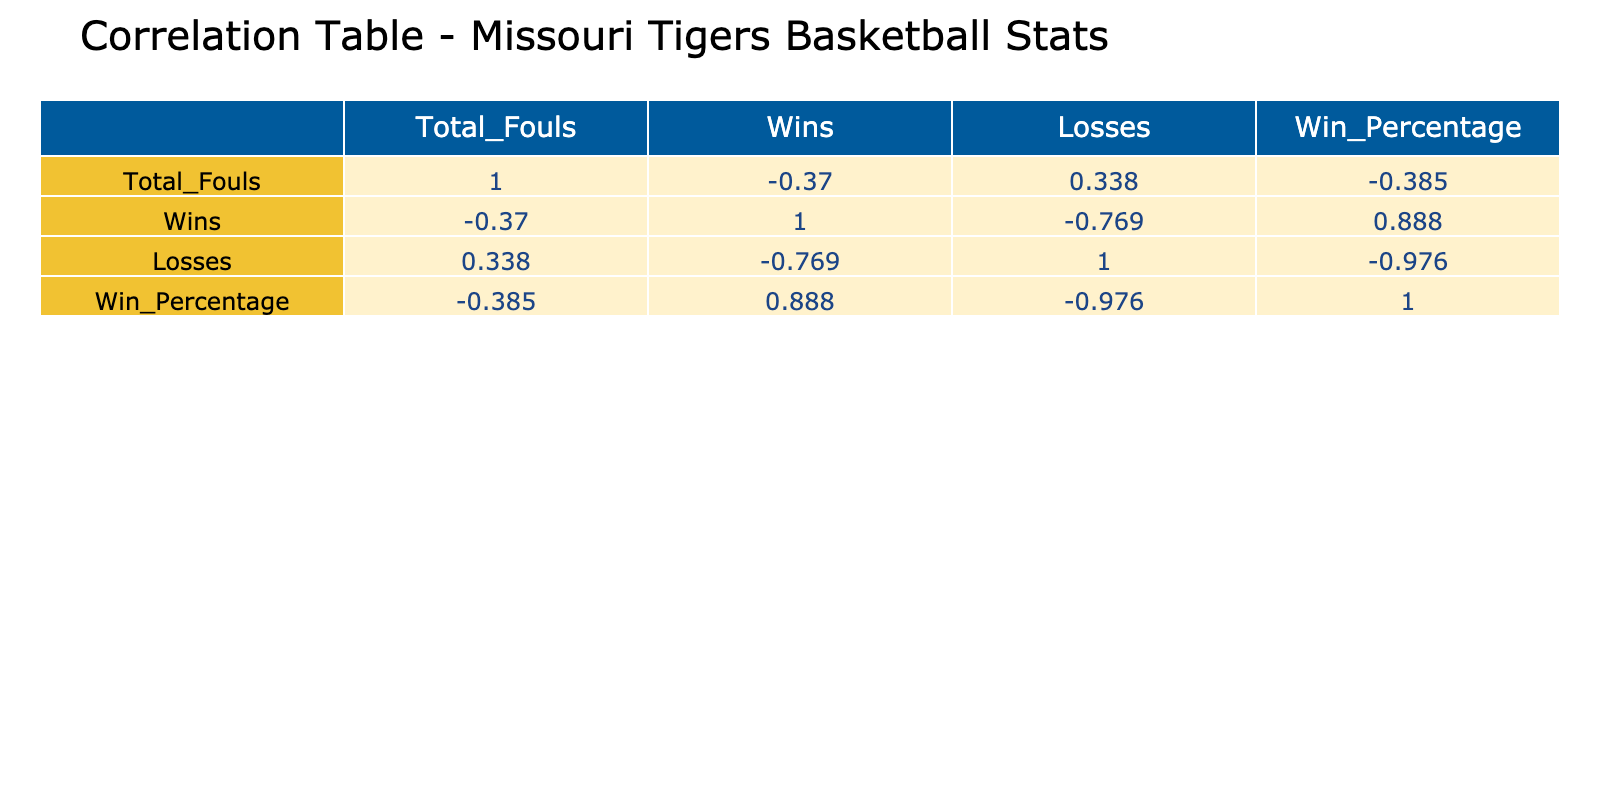What season had the highest number of total fouls? By looking at the Total_Fouls column in the table, the highest value is 670, which corresponds to the 2022-23 season.
Answer: 2022-23 What is the win-loss record for the 2021-22 season? The Wins and Losses columns show that the 2021-22 season had 12 wins and 21 losses.
Answer: 12-21 Was the win percentage higher in 2019-20 or 2020-21? Comparing the Win_Percentage values, 2019-20 has a win percentage of 0.625 and 2020-21 has 0.615, thus 2019-20 is higher.
Answer: 2019-20 What is the average win percentage over all seasons? The Win_Percentage values are averaged: (0.468 + 0.625 + 0.615 + 0.364 + 0.219 + 0.647) / 6 = 0.499.
Answer: 0.499 Did the Missouri Tigers have more wins or losses in the 2023-24 season? The 2023-24 season recorded 22 wins and 12 losses, indicating that wins exceeded losses.
Answer: Yes In which season did the team have the lowest win percentage? The table shows that the 2022-23 season has the lowest win percentage of 0.219.
Answer: 2022-23 What is the total number of losses across all seasons? To find this, sum the Losses column values: 17 + 9 + 10 + 21 + 25 + 12 = 94 total losses.
Answer: 94 Was there a season where the total fouls were less than the combined wins and losses? In the 2021-22 season, total fouls were 550 while combined wins and losses (12+21) equal 33, which is less.
Answer: Yes How many more total fouls were recorded in 2022-23 than in 2019-20? The total fouls for 2022-23 is 670 and for 2019-20 is 590. The difference is 670 - 590 = 80.
Answer: 80 